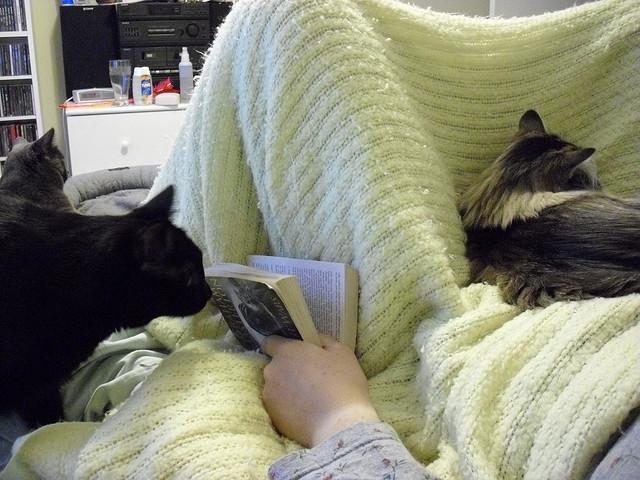How many cats are there?
Give a very brief answer. 3. How many cats are visible?
Give a very brief answer. 3. 